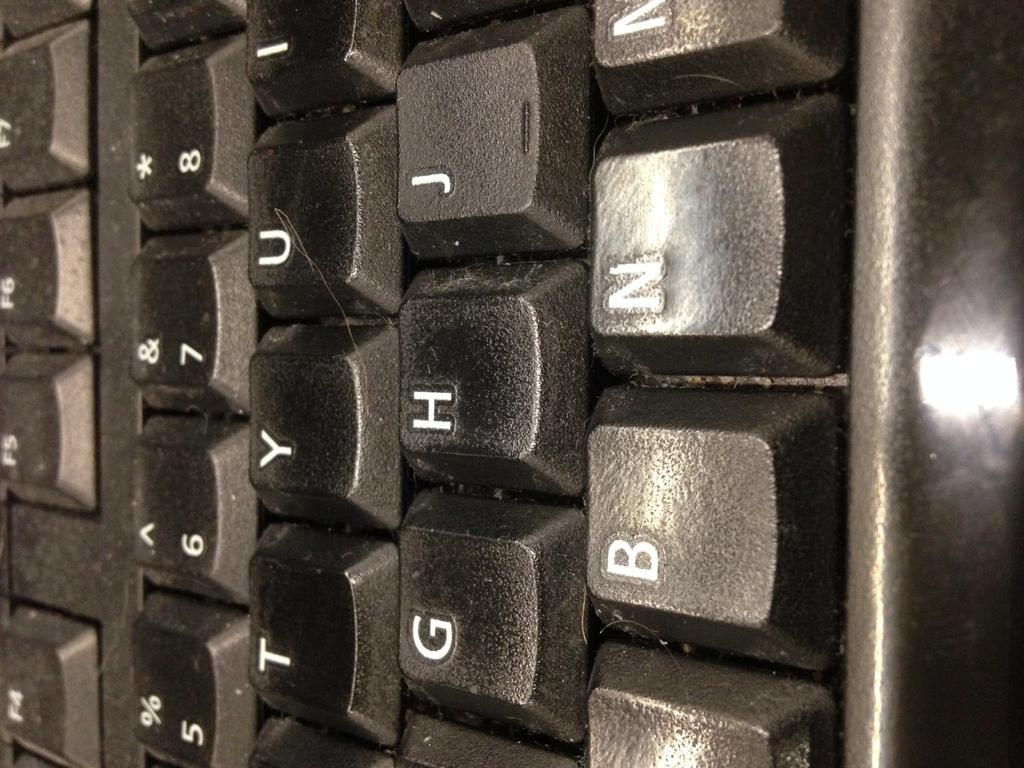<image>
Summarize the visual content of the image. A keyboard's G, H, B and N keys are seen close up. 